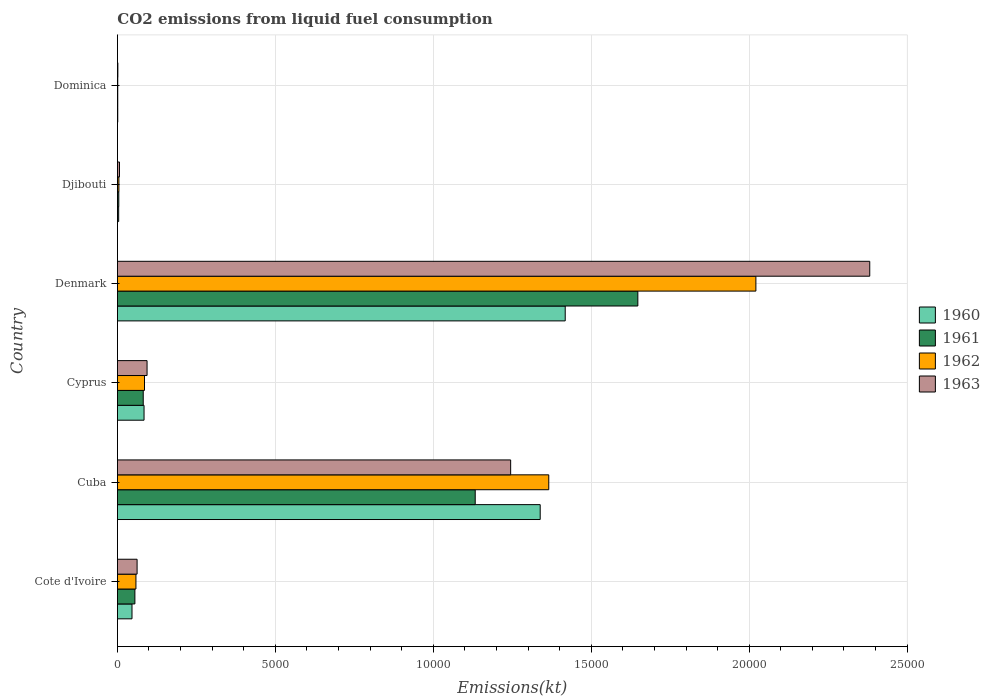How many groups of bars are there?
Your answer should be compact. 6. Are the number of bars per tick equal to the number of legend labels?
Make the answer very short. Yes. How many bars are there on the 5th tick from the bottom?
Provide a succinct answer. 4. What is the label of the 4th group of bars from the top?
Provide a succinct answer. Cyprus. What is the amount of CO2 emitted in 1961 in Denmark?
Your answer should be very brief. 1.65e+04. Across all countries, what is the maximum amount of CO2 emitted in 1963?
Offer a terse response. 2.38e+04. Across all countries, what is the minimum amount of CO2 emitted in 1963?
Make the answer very short. 14.67. In which country was the amount of CO2 emitted in 1961 maximum?
Keep it short and to the point. Denmark. In which country was the amount of CO2 emitted in 1961 minimum?
Offer a very short reply. Dominica. What is the total amount of CO2 emitted in 1961 in the graph?
Your answer should be very brief. 2.92e+04. What is the difference between the amount of CO2 emitted in 1962 in Cote d'Ivoire and that in Dominica?
Your answer should be compact. 575.72. What is the difference between the amount of CO2 emitted in 1963 in Cyprus and the amount of CO2 emitted in 1961 in Cote d'Ivoire?
Your answer should be compact. 385.03. What is the average amount of CO2 emitted in 1961 per country?
Your answer should be very brief. 4871.61. What is the difference between the amount of CO2 emitted in 1961 and amount of CO2 emitted in 1963 in Cyprus?
Your answer should be compact. -121.01. In how many countries, is the amount of CO2 emitted in 1963 greater than 15000 kt?
Make the answer very short. 1. What is the ratio of the amount of CO2 emitted in 1960 in Cyprus to that in Dominica?
Provide a short and direct response. 76.67. Is the amount of CO2 emitted in 1960 in Cuba less than that in Denmark?
Your answer should be compact. Yes. What is the difference between the highest and the second highest amount of CO2 emitted in 1960?
Your answer should be compact. 792.07. What is the difference between the highest and the lowest amount of CO2 emitted in 1963?
Make the answer very short. 2.38e+04. What does the 2nd bar from the top in Cyprus represents?
Offer a terse response. 1962. How many countries are there in the graph?
Offer a terse response. 6. How many legend labels are there?
Offer a terse response. 4. What is the title of the graph?
Offer a terse response. CO2 emissions from liquid fuel consumption. Does "2010" appear as one of the legend labels in the graph?
Keep it short and to the point. No. What is the label or title of the X-axis?
Your answer should be very brief. Emissions(kt). What is the label or title of the Y-axis?
Provide a short and direct response. Country. What is the Emissions(kt) of 1960 in Cote d'Ivoire?
Give a very brief answer. 462.04. What is the Emissions(kt) of 1961 in Cote d'Ivoire?
Offer a very short reply. 553.72. What is the Emissions(kt) in 1962 in Cote d'Ivoire?
Your response must be concise. 586.72. What is the Emissions(kt) of 1963 in Cote d'Ivoire?
Offer a very short reply. 623.39. What is the Emissions(kt) of 1960 in Cuba?
Provide a succinct answer. 1.34e+04. What is the Emissions(kt) in 1961 in Cuba?
Ensure brevity in your answer.  1.13e+04. What is the Emissions(kt) in 1962 in Cuba?
Make the answer very short. 1.37e+04. What is the Emissions(kt) of 1963 in Cuba?
Provide a short and direct response. 1.24e+04. What is the Emissions(kt) of 1960 in Cyprus?
Offer a terse response. 843.41. What is the Emissions(kt) in 1961 in Cyprus?
Ensure brevity in your answer.  817.74. What is the Emissions(kt) in 1962 in Cyprus?
Your answer should be compact. 858.08. What is the Emissions(kt) of 1963 in Cyprus?
Offer a terse response. 938.75. What is the Emissions(kt) of 1960 in Denmark?
Offer a very short reply. 1.42e+04. What is the Emissions(kt) of 1961 in Denmark?
Your response must be concise. 1.65e+04. What is the Emissions(kt) of 1962 in Denmark?
Keep it short and to the point. 2.02e+04. What is the Emissions(kt) in 1963 in Denmark?
Make the answer very short. 2.38e+04. What is the Emissions(kt) of 1960 in Djibouti?
Your answer should be compact. 40.34. What is the Emissions(kt) of 1961 in Djibouti?
Make the answer very short. 44. What is the Emissions(kt) in 1962 in Djibouti?
Give a very brief answer. 47.67. What is the Emissions(kt) in 1963 in Djibouti?
Make the answer very short. 66.01. What is the Emissions(kt) of 1960 in Dominica?
Make the answer very short. 11. What is the Emissions(kt) in 1961 in Dominica?
Ensure brevity in your answer.  11. What is the Emissions(kt) in 1962 in Dominica?
Your response must be concise. 11. What is the Emissions(kt) of 1963 in Dominica?
Your response must be concise. 14.67. Across all countries, what is the maximum Emissions(kt) of 1960?
Provide a short and direct response. 1.42e+04. Across all countries, what is the maximum Emissions(kt) of 1961?
Give a very brief answer. 1.65e+04. Across all countries, what is the maximum Emissions(kt) in 1962?
Offer a very short reply. 2.02e+04. Across all countries, what is the maximum Emissions(kt) in 1963?
Offer a very short reply. 2.38e+04. Across all countries, what is the minimum Emissions(kt) in 1960?
Provide a succinct answer. 11. Across all countries, what is the minimum Emissions(kt) in 1961?
Your answer should be very brief. 11. Across all countries, what is the minimum Emissions(kt) of 1962?
Make the answer very short. 11. Across all countries, what is the minimum Emissions(kt) in 1963?
Provide a succinct answer. 14.67. What is the total Emissions(kt) of 1960 in the graph?
Give a very brief answer. 2.89e+04. What is the total Emissions(kt) in 1961 in the graph?
Offer a very short reply. 2.92e+04. What is the total Emissions(kt) in 1962 in the graph?
Offer a very short reply. 3.54e+04. What is the total Emissions(kt) in 1963 in the graph?
Your response must be concise. 3.79e+04. What is the difference between the Emissions(kt) in 1960 in Cote d'Ivoire and that in Cuba?
Your response must be concise. -1.29e+04. What is the difference between the Emissions(kt) in 1961 in Cote d'Ivoire and that in Cuba?
Give a very brief answer. -1.08e+04. What is the difference between the Emissions(kt) in 1962 in Cote d'Ivoire and that in Cuba?
Offer a very short reply. -1.31e+04. What is the difference between the Emissions(kt) of 1963 in Cote d'Ivoire and that in Cuba?
Provide a short and direct response. -1.18e+04. What is the difference between the Emissions(kt) in 1960 in Cote d'Ivoire and that in Cyprus?
Offer a terse response. -381.37. What is the difference between the Emissions(kt) of 1961 in Cote d'Ivoire and that in Cyprus?
Provide a short and direct response. -264.02. What is the difference between the Emissions(kt) of 1962 in Cote d'Ivoire and that in Cyprus?
Provide a short and direct response. -271.36. What is the difference between the Emissions(kt) in 1963 in Cote d'Ivoire and that in Cyprus?
Offer a very short reply. -315.36. What is the difference between the Emissions(kt) of 1960 in Cote d'Ivoire and that in Denmark?
Offer a terse response. -1.37e+04. What is the difference between the Emissions(kt) in 1961 in Cote d'Ivoire and that in Denmark?
Make the answer very short. -1.59e+04. What is the difference between the Emissions(kt) in 1962 in Cote d'Ivoire and that in Denmark?
Provide a succinct answer. -1.96e+04. What is the difference between the Emissions(kt) in 1963 in Cote d'Ivoire and that in Denmark?
Provide a succinct answer. -2.32e+04. What is the difference between the Emissions(kt) of 1960 in Cote d'Ivoire and that in Djibouti?
Your answer should be compact. 421.7. What is the difference between the Emissions(kt) in 1961 in Cote d'Ivoire and that in Djibouti?
Offer a terse response. 509.71. What is the difference between the Emissions(kt) in 1962 in Cote d'Ivoire and that in Djibouti?
Keep it short and to the point. 539.05. What is the difference between the Emissions(kt) of 1963 in Cote d'Ivoire and that in Djibouti?
Your answer should be compact. 557.38. What is the difference between the Emissions(kt) in 1960 in Cote d'Ivoire and that in Dominica?
Offer a terse response. 451.04. What is the difference between the Emissions(kt) in 1961 in Cote d'Ivoire and that in Dominica?
Your answer should be very brief. 542.72. What is the difference between the Emissions(kt) in 1962 in Cote d'Ivoire and that in Dominica?
Provide a short and direct response. 575.72. What is the difference between the Emissions(kt) in 1963 in Cote d'Ivoire and that in Dominica?
Provide a short and direct response. 608.72. What is the difference between the Emissions(kt) in 1960 in Cuba and that in Cyprus?
Keep it short and to the point. 1.25e+04. What is the difference between the Emissions(kt) of 1961 in Cuba and that in Cyprus?
Give a very brief answer. 1.05e+04. What is the difference between the Emissions(kt) in 1962 in Cuba and that in Cyprus?
Make the answer very short. 1.28e+04. What is the difference between the Emissions(kt) in 1963 in Cuba and that in Cyprus?
Keep it short and to the point. 1.15e+04. What is the difference between the Emissions(kt) of 1960 in Cuba and that in Denmark?
Your answer should be very brief. -792.07. What is the difference between the Emissions(kt) in 1961 in Cuba and that in Denmark?
Ensure brevity in your answer.  -5148.47. What is the difference between the Emissions(kt) of 1962 in Cuba and that in Denmark?
Give a very brief answer. -6556.6. What is the difference between the Emissions(kt) in 1963 in Cuba and that in Denmark?
Ensure brevity in your answer.  -1.14e+04. What is the difference between the Emissions(kt) in 1960 in Cuba and that in Djibouti?
Your answer should be compact. 1.33e+04. What is the difference between the Emissions(kt) of 1961 in Cuba and that in Djibouti?
Your response must be concise. 1.13e+04. What is the difference between the Emissions(kt) of 1962 in Cuba and that in Djibouti?
Offer a very short reply. 1.36e+04. What is the difference between the Emissions(kt) of 1963 in Cuba and that in Djibouti?
Give a very brief answer. 1.24e+04. What is the difference between the Emissions(kt) of 1960 in Cuba and that in Dominica?
Offer a terse response. 1.34e+04. What is the difference between the Emissions(kt) of 1961 in Cuba and that in Dominica?
Ensure brevity in your answer.  1.13e+04. What is the difference between the Emissions(kt) in 1962 in Cuba and that in Dominica?
Your answer should be very brief. 1.36e+04. What is the difference between the Emissions(kt) of 1963 in Cuba and that in Dominica?
Provide a succinct answer. 1.24e+04. What is the difference between the Emissions(kt) in 1960 in Cyprus and that in Denmark?
Ensure brevity in your answer.  -1.33e+04. What is the difference between the Emissions(kt) in 1961 in Cyprus and that in Denmark?
Offer a terse response. -1.57e+04. What is the difference between the Emissions(kt) of 1962 in Cyprus and that in Denmark?
Keep it short and to the point. -1.94e+04. What is the difference between the Emissions(kt) of 1963 in Cyprus and that in Denmark?
Provide a succinct answer. -2.29e+04. What is the difference between the Emissions(kt) of 1960 in Cyprus and that in Djibouti?
Offer a terse response. 803.07. What is the difference between the Emissions(kt) in 1961 in Cyprus and that in Djibouti?
Your answer should be compact. 773.74. What is the difference between the Emissions(kt) of 1962 in Cyprus and that in Djibouti?
Provide a succinct answer. 810.41. What is the difference between the Emissions(kt) of 1963 in Cyprus and that in Djibouti?
Ensure brevity in your answer.  872.75. What is the difference between the Emissions(kt) in 1960 in Cyprus and that in Dominica?
Offer a terse response. 832.41. What is the difference between the Emissions(kt) in 1961 in Cyprus and that in Dominica?
Give a very brief answer. 806.74. What is the difference between the Emissions(kt) in 1962 in Cyprus and that in Dominica?
Give a very brief answer. 847.08. What is the difference between the Emissions(kt) in 1963 in Cyprus and that in Dominica?
Make the answer very short. 924.08. What is the difference between the Emissions(kt) of 1960 in Denmark and that in Djibouti?
Your answer should be very brief. 1.41e+04. What is the difference between the Emissions(kt) in 1961 in Denmark and that in Djibouti?
Make the answer very short. 1.64e+04. What is the difference between the Emissions(kt) in 1962 in Denmark and that in Djibouti?
Keep it short and to the point. 2.02e+04. What is the difference between the Emissions(kt) in 1963 in Denmark and that in Djibouti?
Offer a terse response. 2.38e+04. What is the difference between the Emissions(kt) of 1960 in Denmark and that in Dominica?
Your answer should be compact. 1.42e+04. What is the difference between the Emissions(kt) in 1961 in Denmark and that in Dominica?
Offer a very short reply. 1.65e+04. What is the difference between the Emissions(kt) in 1962 in Denmark and that in Dominica?
Ensure brevity in your answer.  2.02e+04. What is the difference between the Emissions(kt) of 1963 in Denmark and that in Dominica?
Your answer should be very brief. 2.38e+04. What is the difference between the Emissions(kt) of 1960 in Djibouti and that in Dominica?
Offer a terse response. 29.34. What is the difference between the Emissions(kt) of 1961 in Djibouti and that in Dominica?
Offer a very short reply. 33. What is the difference between the Emissions(kt) in 1962 in Djibouti and that in Dominica?
Your answer should be compact. 36.67. What is the difference between the Emissions(kt) of 1963 in Djibouti and that in Dominica?
Keep it short and to the point. 51.34. What is the difference between the Emissions(kt) of 1960 in Cote d'Ivoire and the Emissions(kt) of 1961 in Cuba?
Keep it short and to the point. -1.09e+04. What is the difference between the Emissions(kt) of 1960 in Cote d'Ivoire and the Emissions(kt) of 1962 in Cuba?
Offer a very short reply. -1.32e+04. What is the difference between the Emissions(kt) in 1960 in Cote d'Ivoire and the Emissions(kt) in 1963 in Cuba?
Give a very brief answer. -1.20e+04. What is the difference between the Emissions(kt) in 1961 in Cote d'Ivoire and the Emissions(kt) in 1962 in Cuba?
Provide a succinct answer. -1.31e+04. What is the difference between the Emissions(kt) in 1961 in Cote d'Ivoire and the Emissions(kt) in 1963 in Cuba?
Provide a succinct answer. -1.19e+04. What is the difference between the Emissions(kt) of 1962 in Cote d'Ivoire and the Emissions(kt) of 1963 in Cuba?
Your answer should be very brief. -1.19e+04. What is the difference between the Emissions(kt) in 1960 in Cote d'Ivoire and the Emissions(kt) in 1961 in Cyprus?
Offer a terse response. -355.7. What is the difference between the Emissions(kt) of 1960 in Cote d'Ivoire and the Emissions(kt) of 1962 in Cyprus?
Your answer should be very brief. -396.04. What is the difference between the Emissions(kt) in 1960 in Cote d'Ivoire and the Emissions(kt) in 1963 in Cyprus?
Your answer should be very brief. -476.71. What is the difference between the Emissions(kt) in 1961 in Cote d'Ivoire and the Emissions(kt) in 1962 in Cyprus?
Your response must be concise. -304.36. What is the difference between the Emissions(kt) in 1961 in Cote d'Ivoire and the Emissions(kt) in 1963 in Cyprus?
Keep it short and to the point. -385.04. What is the difference between the Emissions(kt) of 1962 in Cote d'Ivoire and the Emissions(kt) of 1963 in Cyprus?
Ensure brevity in your answer.  -352.03. What is the difference between the Emissions(kt) in 1960 in Cote d'Ivoire and the Emissions(kt) in 1961 in Denmark?
Ensure brevity in your answer.  -1.60e+04. What is the difference between the Emissions(kt) of 1960 in Cote d'Ivoire and the Emissions(kt) of 1962 in Denmark?
Provide a short and direct response. -1.98e+04. What is the difference between the Emissions(kt) in 1960 in Cote d'Ivoire and the Emissions(kt) in 1963 in Denmark?
Your answer should be very brief. -2.34e+04. What is the difference between the Emissions(kt) of 1961 in Cote d'Ivoire and the Emissions(kt) of 1962 in Denmark?
Your response must be concise. -1.97e+04. What is the difference between the Emissions(kt) in 1961 in Cote d'Ivoire and the Emissions(kt) in 1963 in Denmark?
Offer a very short reply. -2.33e+04. What is the difference between the Emissions(kt) of 1962 in Cote d'Ivoire and the Emissions(kt) of 1963 in Denmark?
Give a very brief answer. -2.32e+04. What is the difference between the Emissions(kt) of 1960 in Cote d'Ivoire and the Emissions(kt) of 1961 in Djibouti?
Your response must be concise. 418.04. What is the difference between the Emissions(kt) in 1960 in Cote d'Ivoire and the Emissions(kt) in 1962 in Djibouti?
Give a very brief answer. 414.37. What is the difference between the Emissions(kt) in 1960 in Cote d'Ivoire and the Emissions(kt) in 1963 in Djibouti?
Provide a short and direct response. 396.04. What is the difference between the Emissions(kt) of 1961 in Cote d'Ivoire and the Emissions(kt) of 1962 in Djibouti?
Offer a very short reply. 506.05. What is the difference between the Emissions(kt) of 1961 in Cote d'Ivoire and the Emissions(kt) of 1963 in Djibouti?
Your response must be concise. 487.71. What is the difference between the Emissions(kt) in 1962 in Cote d'Ivoire and the Emissions(kt) in 1963 in Djibouti?
Your answer should be compact. 520.71. What is the difference between the Emissions(kt) in 1960 in Cote d'Ivoire and the Emissions(kt) in 1961 in Dominica?
Make the answer very short. 451.04. What is the difference between the Emissions(kt) in 1960 in Cote d'Ivoire and the Emissions(kt) in 1962 in Dominica?
Give a very brief answer. 451.04. What is the difference between the Emissions(kt) in 1960 in Cote d'Ivoire and the Emissions(kt) in 1963 in Dominica?
Provide a succinct answer. 447.37. What is the difference between the Emissions(kt) of 1961 in Cote d'Ivoire and the Emissions(kt) of 1962 in Dominica?
Your answer should be compact. 542.72. What is the difference between the Emissions(kt) of 1961 in Cote d'Ivoire and the Emissions(kt) of 1963 in Dominica?
Keep it short and to the point. 539.05. What is the difference between the Emissions(kt) of 1962 in Cote d'Ivoire and the Emissions(kt) of 1963 in Dominica?
Your response must be concise. 572.05. What is the difference between the Emissions(kt) of 1960 in Cuba and the Emissions(kt) of 1961 in Cyprus?
Offer a terse response. 1.26e+04. What is the difference between the Emissions(kt) of 1960 in Cuba and the Emissions(kt) of 1962 in Cyprus?
Your answer should be very brief. 1.25e+04. What is the difference between the Emissions(kt) of 1960 in Cuba and the Emissions(kt) of 1963 in Cyprus?
Offer a terse response. 1.24e+04. What is the difference between the Emissions(kt) in 1961 in Cuba and the Emissions(kt) in 1962 in Cyprus?
Ensure brevity in your answer.  1.05e+04. What is the difference between the Emissions(kt) of 1961 in Cuba and the Emissions(kt) of 1963 in Cyprus?
Make the answer very short. 1.04e+04. What is the difference between the Emissions(kt) in 1962 in Cuba and the Emissions(kt) in 1963 in Cyprus?
Offer a terse response. 1.27e+04. What is the difference between the Emissions(kt) in 1960 in Cuba and the Emissions(kt) in 1961 in Denmark?
Offer a terse response. -3091.28. What is the difference between the Emissions(kt) of 1960 in Cuba and the Emissions(kt) of 1962 in Denmark?
Provide a short and direct response. -6827.95. What is the difference between the Emissions(kt) of 1960 in Cuba and the Emissions(kt) of 1963 in Denmark?
Provide a succinct answer. -1.04e+04. What is the difference between the Emissions(kt) in 1961 in Cuba and the Emissions(kt) in 1962 in Denmark?
Offer a terse response. -8885.14. What is the difference between the Emissions(kt) of 1961 in Cuba and the Emissions(kt) of 1963 in Denmark?
Provide a short and direct response. -1.25e+04. What is the difference between the Emissions(kt) of 1962 in Cuba and the Emissions(kt) of 1963 in Denmark?
Your answer should be very brief. -1.02e+04. What is the difference between the Emissions(kt) in 1960 in Cuba and the Emissions(kt) in 1961 in Djibouti?
Make the answer very short. 1.33e+04. What is the difference between the Emissions(kt) in 1960 in Cuba and the Emissions(kt) in 1962 in Djibouti?
Your answer should be compact. 1.33e+04. What is the difference between the Emissions(kt) of 1960 in Cuba and the Emissions(kt) of 1963 in Djibouti?
Keep it short and to the point. 1.33e+04. What is the difference between the Emissions(kt) of 1961 in Cuba and the Emissions(kt) of 1962 in Djibouti?
Provide a succinct answer. 1.13e+04. What is the difference between the Emissions(kt) in 1961 in Cuba and the Emissions(kt) in 1963 in Djibouti?
Ensure brevity in your answer.  1.13e+04. What is the difference between the Emissions(kt) of 1962 in Cuba and the Emissions(kt) of 1963 in Djibouti?
Offer a terse response. 1.36e+04. What is the difference between the Emissions(kt) in 1960 in Cuba and the Emissions(kt) in 1961 in Dominica?
Ensure brevity in your answer.  1.34e+04. What is the difference between the Emissions(kt) in 1960 in Cuba and the Emissions(kt) in 1962 in Dominica?
Keep it short and to the point. 1.34e+04. What is the difference between the Emissions(kt) of 1960 in Cuba and the Emissions(kt) of 1963 in Dominica?
Provide a succinct answer. 1.34e+04. What is the difference between the Emissions(kt) in 1961 in Cuba and the Emissions(kt) in 1962 in Dominica?
Make the answer very short. 1.13e+04. What is the difference between the Emissions(kt) of 1961 in Cuba and the Emissions(kt) of 1963 in Dominica?
Ensure brevity in your answer.  1.13e+04. What is the difference between the Emissions(kt) of 1962 in Cuba and the Emissions(kt) of 1963 in Dominica?
Keep it short and to the point. 1.36e+04. What is the difference between the Emissions(kt) in 1960 in Cyprus and the Emissions(kt) in 1961 in Denmark?
Keep it short and to the point. -1.56e+04. What is the difference between the Emissions(kt) of 1960 in Cyprus and the Emissions(kt) of 1962 in Denmark?
Your answer should be very brief. -1.94e+04. What is the difference between the Emissions(kt) of 1960 in Cyprus and the Emissions(kt) of 1963 in Denmark?
Make the answer very short. -2.30e+04. What is the difference between the Emissions(kt) of 1961 in Cyprus and the Emissions(kt) of 1962 in Denmark?
Your response must be concise. -1.94e+04. What is the difference between the Emissions(kt) of 1961 in Cyprus and the Emissions(kt) of 1963 in Denmark?
Your response must be concise. -2.30e+04. What is the difference between the Emissions(kt) of 1962 in Cyprus and the Emissions(kt) of 1963 in Denmark?
Your response must be concise. -2.30e+04. What is the difference between the Emissions(kt) in 1960 in Cyprus and the Emissions(kt) in 1961 in Djibouti?
Give a very brief answer. 799.41. What is the difference between the Emissions(kt) in 1960 in Cyprus and the Emissions(kt) in 1962 in Djibouti?
Your answer should be very brief. 795.74. What is the difference between the Emissions(kt) in 1960 in Cyprus and the Emissions(kt) in 1963 in Djibouti?
Provide a short and direct response. 777.4. What is the difference between the Emissions(kt) of 1961 in Cyprus and the Emissions(kt) of 1962 in Djibouti?
Make the answer very short. 770.07. What is the difference between the Emissions(kt) of 1961 in Cyprus and the Emissions(kt) of 1963 in Djibouti?
Your answer should be very brief. 751.74. What is the difference between the Emissions(kt) of 1962 in Cyprus and the Emissions(kt) of 1963 in Djibouti?
Your response must be concise. 792.07. What is the difference between the Emissions(kt) of 1960 in Cyprus and the Emissions(kt) of 1961 in Dominica?
Your response must be concise. 832.41. What is the difference between the Emissions(kt) of 1960 in Cyprus and the Emissions(kt) of 1962 in Dominica?
Provide a short and direct response. 832.41. What is the difference between the Emissions(kt) in 1960 in Cyprus and the Emissions(kt) in 1963 in Dominica?
Provide a succinct answer. 828.74. What is the difference between the Emissions(kt) of 1961 in Cyprus and the Emissions(kt) of 1962 in Dominica?
Keep it short and to the point. 806.74. What is the difference between the Emissions(kt) in 1961 in Cyprus and the Emissions(kt) in 1963 in Dominica?
Provide a succinct answer. 803.07. What is the difference between the Emissions(kt) in 1962 in Cyprus and the Emissions(kt) in 1963 in Dominica?
Provide a succinct answer. 843.41. What is the difference between the Emissions(kt) of 1960 in Denmark and the Emissions(kt) of 1961 in Djibouti?
Keep it short and to the point. 1.41e+04. What is the difference between the Emissions(kt) in 1960 in Denmark and the Emissions(kt) in 1962 in Djibouti?
Ensure brevity in your answer.  1.41e+04. What is the difference between the Emissions(kt) of 1960 in Denmark and the Emissions(kt) of 1963 in Djibouti?
Make the answer very short. 1.41e+04. What is the difference between the Emissions(kt) in 1961 in Denmark and the Emissions(kt) in 1962 in Djibouti?
Provide a succinct answer. 1.64e+04. What is the difference between the Emissions(kt) in 1961 in Denmark and the Emissions(kt) in 1963 in Djibouti?
Give a very brief answer. 1.64e+04. What is the difference between the Emissions(kt) of 1962 in Denmark and the Emissions(kt) of 1963 in Djibouti?
Give a very brief answer. 2.01e+04. What is the difference between the Emissions(kt) of 1960 in Denmark and the Emissions(kt) of 1961 in Dominica?
Offer a terse response. 1.42e+04. What is the difference between the Emissions(kt) of 1960 in Denmark and the Emissions(kt) of 1962 in Dominica?
Your response must be concise. 1.42e+04. What is the difference between the Emissions(kt) in 1960 in Denmark and the Emissions(kt) in 1963 in Dominica?
Provide a succinct answer. 1.42e+04. What is the difference between the Emissions(kt) of 1961 in Denmark and the Emissions(kt) of 1962 in Dominica?
Provide a succinct answer. 1.65e+04. What is the difference between the Emissions(kt) of 1961 in Denmark and the Emissions(kt) of 1963 in Dominica?
Your answer should be very brief. 1.65e+04. What is the difference between the Emissions(kt) in 1962 in Denmark and the Emissions(kt) in 1963 in Dominica?
Your answer should be very brief. 2.02e+04. What is the difference between the Emissions(kt) of 1960 in Djibouti and the Emissions(kt) of 1961 in Dominica?
Give a very brief answer. 29.34. What is the difference between the Emissions(kt) of 1960 in Djibouti and the Emissions(kt) of 1962 in Dominica?
Offer a very short reply. 29.34. What is the difference between the Emissions(kt) of 1960 in Djibouti and the Emissions(kt) of 1963 in Dominica?
Ensure brevity in your answer.  25.67. What is the difference between the Emissions(kt) in 1961 in Djibouti and the Emissions(kt) in 1962 in Dominica?
Provide a succinct answer. 33. What is the difference between the Emissions(kt) in 1961 in Djibouti and the Emissions(kt) in 1963 in Dominica?
Your answer should be very brief. 29.34. What is the difference between the Emissions(kt) in 1962 in Djibouti and the Emissions(kt) in 1963 in Dominica?
Offer a very short reply. 33. What is the average Emissions(kt) in 1960 per country?
Provide a succinct answer. 4819.66. What is the average Emissions(kt) in 1961 per country?
Offer a very short reply. 4871.61. What is the average Emissions(kt) in 1962 per country?
Provide a succinct answer. 5895.31. What is the average Emissions(kt) of 1963 per country?
Your answer should be compact. 6318.24. What is the difference between the Emissions(kt) in 1960 and Emissions(kt) in 1961 in Cote d'Ivoire?
Your response must be concise. -91.67. What is the difference between the Emissions(kt) in 1960 and Emissions(kt) in 1962 in Cote d'Ivoire?
Keep it short and to the point. -124.68. What is the difference between the Emissions(kt) in 1960 and Emissions(kt) in 1963 in Cote d'Ivoire?
Your response must be concise. -161.35. What is the difference between the Emissions(kt) of 1961 and Emissions(kt) of 1962 in Cote d'Ivoire?
Your answer should be very brief. -33. What is the difference between the Emissions(kt) in 1961 and Emissions(kt) in 1963 in Cote d'Ivoire?
Make the answer very short. -69.67. What is the difference between the Emissions(kt) in 1962 and Emissions(kt) in 1963 in Cote d'Ivoire?
Provide a succinct answer. -36.67. What is the difference between the Emissions(kt) in 1960 and Emissions(kt) in 1961 in Cuba?
Give a very brief answer. 2057.19. What is the difference between the Emissions(kt) in 1960 and Emissions(kt) in 1962 in Cuba?
Your response must be concise. -271.36. What is the difference between the Emissions(kt) of 1960 and Emissions(kt) of 1963 in Cuba?
Keep it short and to the point. 935.09. What is the difference between the Emissions(kt) in 1961 and Emissions(kt) in 1962 in Cuba?
Your answer should be compact. -2328.55. What is the difference between the Emissions(kt) of 1961 and Emissions(kt) of 1963 in Cuba?
Ensure brevity in your answer.  -1122.1. What is the difference between the Emissions(kt) in 1962 and Emissions(kt) in 1963 in Cuba?
Offer a terse response. 1206.44. What is the difference between the Emissions(kt) of 1960 and Emissions(kt) of 1961 in Cyprus?
Give a very brief answer. 25.67. What is the difference between the Emissions(kt) of 1960 and Emissions(kt) of 1962 in Cyprus?
Your answer should be compact. -14.67. What is the difference between the Emissions(kt) of 1960 and Emissions(kt) of 1963 in Cyprus?
Provide a succinct answer. -95.34. What is the difference between the Emissions(kt) of 1961 and Emissions(kt) of 1962 in Cyprus?
Your response must be concise. -40.34. What is the difference between the Emissions(kt) of 1961 and Emissions(kt) of 1963 in Cyprus?
Your response must be concise. -121.01. What is the difference between the Emissions(kt) in 1962 and Emissions(kt) in 1963 in Cyprus?
Offer a very short reply. -80.67. What is the difference between the Emissions(kt) in 1960 and Emissions(kt) in 1961 in Denmark?
Your answer should be compact. -2299.21. What is the difference between the Emissions(kt) of 1960 and Emissions(kt) of 1962 in Denmark?
Your answer should be compact. -6035.88. What is the difference between the Emissions(kt) in 1960 and Emissions(kt) in 1963 in Denmark?
Your answer should be compact. -9640.54. What is the difference between the Emissions(kt) in 1961 and Emissions(kt) in 1962 in Denmark?
Ensure brevity in your answer.  -3736.67. What is the difference between the Emissions(kt) of 1961 and Emissions(kt) of 1963 in Denmark?
Ensure brevity in your answer.  -7341.33. What is the difference between the Emissions(kt) in 1962 and Emissions(kt) in 1963 in Denmark?
Keep it short and to the point. -3604.66. What is the difference between the Emissions(kt) of 1960 and Emissions(kt) of 1961 in Djibouti?
Give a very brief answer. -3.67. What is the difference between the Emissions(kt) in 1960 and Emissions(kt) in 1962 in Djibouti?
Make the answer very short. -7.33. What is the difference between the Emissions(kt) of 1960 and Emissions(kt) of 1963 in Djibouti?
Provide a short and direct response. -25.67. What is the difference between the Emissions(kt) of 1961 and Emissions(kt) of 1962 in Djibouti?
Offer a terse response. -3.67. What is the difference between the Emissions(kt) in 1961 and Emissions(kt) in 1963 in Djibouti?
Keep it short and to the point. -22. What is the difference between the Emissions(kt) of 1962 and Emissions(kt) of 1963 in Djibouti?
Provide a short and direct response. -18.34. What is the difference between the Emissions(kt) in 1960 and Emissions(kt) in 1961 in Dominica?
Offer a very short reply. 0. What is the difference between the Emissions(kt) of 1960 and Emissions(kt) of 1963 in Dominica?
Provide a succinct answer. -3.67. What is the difference between the Emissions(kt) of 1961 and Emissions(kt) of 1962 in Dominica?
Offer a very short reply. 0. What is the difference between the Emissions(kt) in 1961 and Emissions(kt) in 1963 in Dominica?
Your answer should be compact. -3.67. What is the difference between the Emissions(kt) of 1962 and Emissions(kt) of 1963 in Dominica?
Your answer should be compact. -3.67. What is the ratio of the Emissions(kt) in 1960 in Cote d'Ivoire to that in Cuba?
Make the answer very short. 0.03. What is the ratio of the Emissions(kt) in 1961 in Cote d'Ivoire to that in Cuba?
Provide a short and direct response. 0.05. What is the ratio of the Emissions(kt) of 1962 in Cote d'Ivoire to that in Cuba?
Ensure brevity in your answer.  0.04. What is the ratio of the Emissions(kt) of 1963 in Cote d'Ivoire to that in Cuba?
Your response must be concise. 0.05. What is the ratio of the Emissions(kt) in 1960 in Cote d'Ivoire to that in Cyprus?
Offer a terse response. 0.55. What is the ratio of the Emissions(kt) in 1961 in Cote d'Ivoire to that in Cyprus?
Your response must be concise. 0.68. What is the ratio of the Emissions(kt) in 1962 in Cote d'Ivoire to that in Cyprus?
Your response must be concise. 0.68. What is the ratio of the Emissions(kt) of 1963 in Cote d'Ivoire to that in Cyprus?
Ensure brevity in your answer.  0.66. What is the ratio of the Emissions(kt) in 1960 in Cote d'Ivoire to that in Denmark?
Offer a terse response. 0.03. What is the ratio of the Emissions(kt) in 1961 in Cote d'Ivoire to that in Denmark?
Keep it short and to the point. 0.03. What is the ratio of the Emissions(kt) of 1962 in Cote d'Ivoire to that in Denmark?
Your answer should be compact. 0.03. What is the ratio of the Emissions(kt) in 1963 in Cote d'Ivoire to that in Denmark?
Your answer should be compact. 0.03. What is the ratio of the Emissions(kt) of 1960 in Cote d'Ivoire to that in Djibouti?
Provide a short and direct response. 11.45. What is the ratio of the Emissions(kt) in 1961 in Cote d'Ivoire to that in Djibouti?
Your answer should be very brief. 12.58. What is the ratio of the Emissions(kt) of 1962 in Cote d'Ivoire to that in Djibouti?
Your response must be concise. 12.31. What is the ratio of the Emissions(kt) of 1963 in Cote d'Ivoire to that in Djibouti?
Keep it short and to the point. 9.44. What is the ratio of the Emissions(kt) of 1961 in Cote d'Ivoire to that in Dominica?
Offer a terse response. 50.33. What is the ratio of the Emissions(kt) in 1962 in Cote d'Ivoire to that in Dominica?
Your answer should be compact. 53.33. What is the ratio of the Emissions(kt) in 1963 in Cote d'Ivoire to that in Dominica?
Provide a short and direct response. 42.5. What is the ratio of the Emissions(kt) in 1960 in Cuba to that in Cyprus?
Give a very brief answer. 15.87. What is the ratio of the Emissions(kt) in 1961 in Cuba to that in Cyprus?
Your answer should be compact. 13.85. What is the ratio of the Emissions(kt) in 1962 in Cuba to that in Cyprus?
Offer a very short reply. 15.91. What is the ratio of the Emissions(kt) in 1963 in Cuba to that in Cyprus?
Offer a terse response. 13.26. What is the ratio of the Emissions(kt) of 1960 in Cuba to that in Denmark?
Ensure brevity in your answer.  0.94. What is the ratio of the Emissions(kt) of 1961 in Cuba to that in Denmark?
Provide a succinct answer. 0.69. What is the ratio of the Emissions(kt) of 1962 in Cuba to that in Denmark?
Make the answer very short. 0.68. What is the ratio of the Emissions(kt) of 1963 in Cuba to that in Denmark?
Give a very brief answer. 0.52. What is the ratio of the Emissions(kt) of 1960 in Cuba to that in Djibouti?
Offer a terse response. 331.82. What is the ratio of the Emissions(kt) in 1961 in Cuba to that in Djibouti?
Make the answer very short. 257.42. What is the ratio of the Emissions(kt) of 1962 in Cuba to that in Djibouti?
Provide a succinct answer. 286.46. What is the ratio of the Emissions(kt) in 1963 in Cuba to that in Djibouti?
Ensure brevity in your answer.  188.61. What is the ratio of the Emissions(kt) in 1960 in Cuba to that in Dominica?
Make the answer very short. 1216.67. What is the ratio of the Emissions(kt) of 1961 in Cuba to that in Dominica?
Keep it short and to the point. 1029.67. What is the ratio of the Emissions(kt) of 1962 in Cuba to that in Dominica?
Ensure brevity in your answer.  1241.33. What is the ratio of the Emissions(kt) in 1963 in Cuba to that in Dominica?
Ensure brevity in your answer.  848.75. What is the ratio of the Emissions(kt) of 1960 in Cyprus to that in Denmark?
Ensure brevity in your answer.  0.06. What is the ratio of the Emissions(kt) of 1961 in Cyprus to that in Denmark?
Your response must be concise. 0.05. What is the ratio of the Emissions(kt) of 1962 in Cyprus to that in Denmark?
Keep it short and to the point. 0.04. What is the ratio of the Emissions(kt) of 1963 in Cyprus to that in Denmark?
Make the answer very short. 0.04. What is the ratio of the Emissions(kt) in 1960 in Cyprus to that in Djibouti?
Your answer should be compact. 20.91. What is the ratio of the Emissions(kt) of 1961 in Cyprus to that in Djibouti?
Give a very brief answer. 18.58. What is the ratio of the Emissions(kt) in 1962 in Cyprus to that in Djibouti?
Offer a terse response. 18. What is the ratio of the Emissions(kt) of 1963 in Cyprus to that in Djibouti?
Give a very brief answer. 14.22. What is the ratio of the Emissions(kt) in 1960 in Cyprus to that in Dominica?
Your answer should be compact. 76.67. What is the ratio of the Emissions(kt) in 1961 in Cyprus to that in Dominica?
Ensure brevity in your answer.  74.33. What is the ratio of the Emissions(kt) of 1962 in Cyprus to that in Dominica?
Make the answer very short. 78. What is the ratio of the Emissions(kt) in 1963 in Cyprus to that in Dominica?
Your response must be concise. 64. What is the ratio of the Emissions(kt) of 1960 in Denmark to that in Djibouti?
Provide a short and direct response. 351.45. What is the ratio of the Emissions(kt) of 1961 in Denmark to that in Djibouti?
Your answer should be compact. 374.42. What is the ratio of the Emissions(kt) in 1962 in Denmark to that in Djibouti?
Give a very brief answer. 424. What is the ratio of the Emissions(kt) of 1963 in Denmark to that in Djibouti?
Offer a very short reply. 360.83. What is the ratio of the Emissions(kt) of 1960 in Denmark to that in Dominica?
Ensure brevity in your answer.  1288.67. What is the ratio of the Emissions(kt) of 1961 in Denmark to that in Dominica?
Offer a terse response. 1497.67. What is the ratio of the Emissions(kt) of 1962 in Denmark to that in Dominica?
Keep it short and to the point. 1837.33. What is the ratio of the Emissions(kt) in 1963 in Denmark to that in Dominica?
Offer a terse response. 1623.75. What is the ratio of the Emissions(kt) of 1960 in Djibouti to that in Dominica?
Your answer should be compact. 3.67. What is the ratio of the Emissions(kt) of 1961 in Djibouti to that in Dominica?
Give a very brief answer. 4. What is the ratio of the Emissions(kt) of 1962 in Djibouti to that in Dominica?
Your response must be concise. 4.33. What is the ratio of the Emissions(kt) of 1963 in Djibouti to that in Dominica?
Provide a short and direct response. 4.5. What is the difference between the highest and the second highest Emissions(kt) in 1960?
Your response must be concise. 792.07. What is the difference between the highest and the second highest Emissions(kt) of 1961?
Ensure brevity in your answer.  5148.47. What is the difference between the highest and the second highest Emissions(kt) in 1962?
Ensure brevity in your answer.  6556.6. What is the difference between the highest and the second highest Emissions(kt) of 1963?
Offer a terse response. 1.14e+04. What is the difference between the highest and the lowest Emissions(kt) in 1960?
Your response must be concise. 1.42e+04. What is the difference between the highest and the lowest Emissions(kt) in 1961?
Your answer should be very brief. 1.65e+04. What is the difference between the highest and the lowest Emissions(kt) in 1962?
Your answer should be very brief. 2.02e+04. What is the difference between the highest and the lowest Emissions(kt) in 1963?
Your answer should be compact. 2.38e+04. 